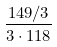Convert formula to latex. <formula><loc_0><loc_0><loc_500><loc_500>\frac { 1 4 9 / 3 } { 3 \cdot 1 1 8 }</formula> 